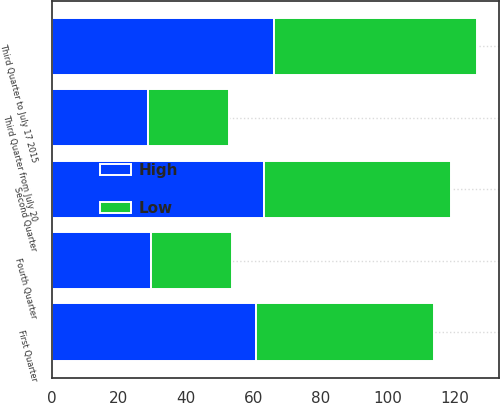Convert chart to OTSL. <chart><loc_0><loc_0><loc_500><loc_500><stacked_bar_chart><ecel><fcel>First Quarter<fcel>Second Quarter<fcel>Third Quarter to July 17 2015<fcel>Third Quarter from July 20<fcel>Fourth Quarter<nl><fcel>High<fcel>60.81<fcel>63.23<fcel>66.29<fcel>28.75<fcel>29.59<nl><fcel>Low<fcel>53<fcel>55.79<fcel>60.43<fcel>24.08<fcel>24<nl></chart> 